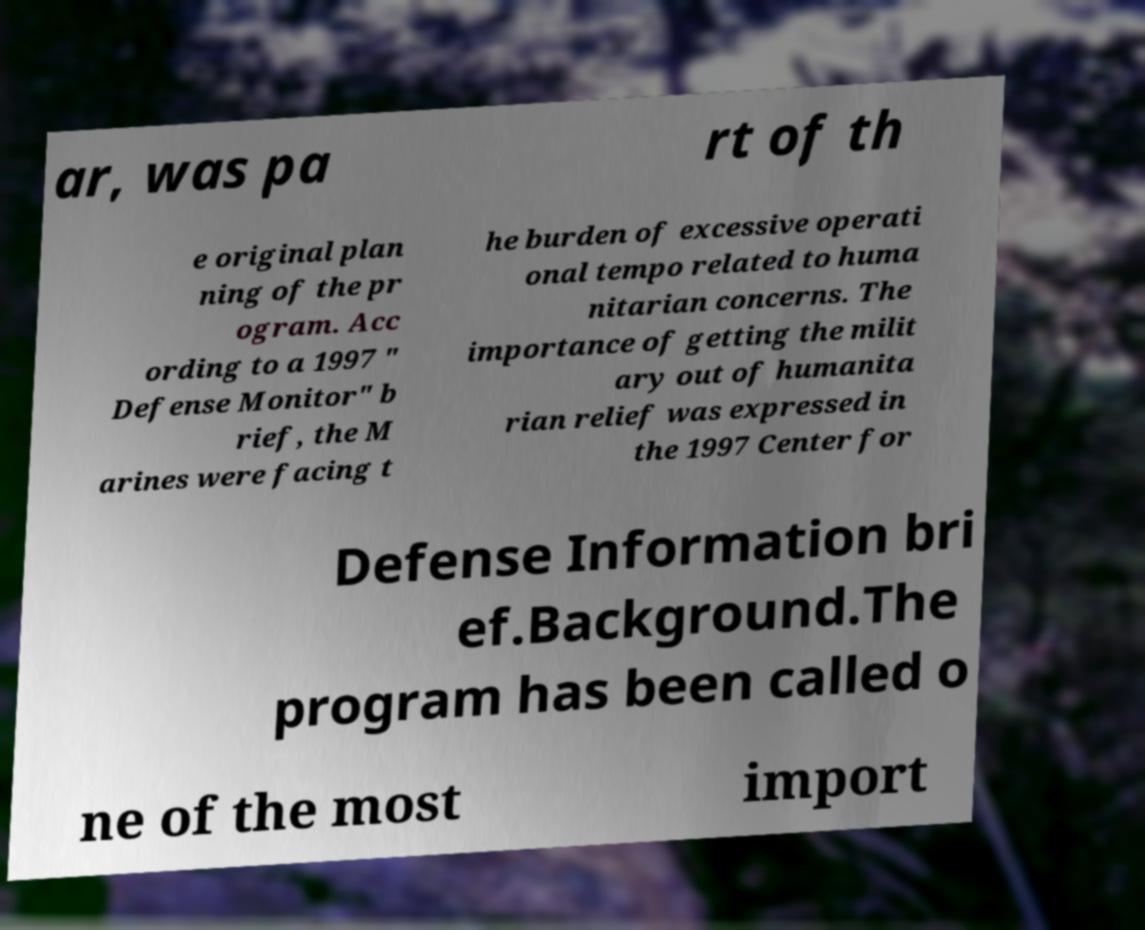I need the written content from this picture converted into text. Can you do that? ar, was pa rt of th e original plan ning of the pr ogram. Acc ording to a 1997 " Defense Monitor" b rief, the M arines were facing t he burden of excessive operati onal tempo related to huma nitarian concerns. The importance of getting the milit ary out of humanita rian relief was expressed in the 1997 Center for Defense Information bri ef.Background.The program has been called o ne of the most import 